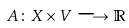<formula> <loc_0><loc_0><loc_500><loc_500>A \colon X \times V \longrightarrow \mathbb { R }</formula> 